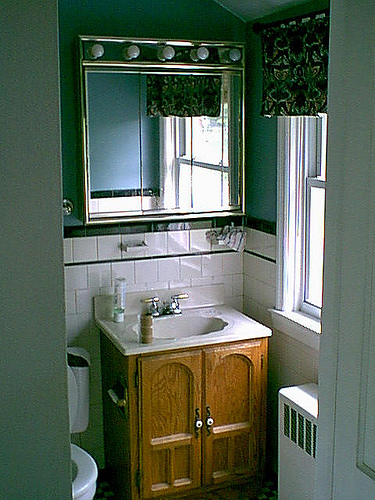<image>Whose bathroom is this? It is ambiguous whose bathroom this is. Whose bathroom is this? It is ambiguous whose bathroom this is. It can be the homeowner's, someone's, or not mine. 